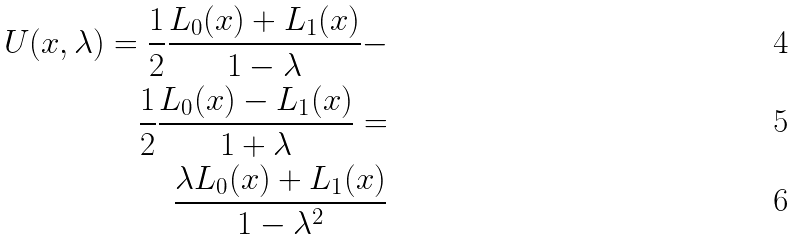<formula> <loc_0><loc_0><loc_500><loc_500>U ( x , \lambda ) = \frac { 1 } { 2 } \frac { L _ { 0 } ( x ) + L _ { 1 } ( x ) } { 1 - \lambda } - \\ \frac { 1 } { 2 } \frac { L _ { 0 } ( x ) - L _ { 1 } ( x ) } { 1 + \lambda } = \\ \frac { \lambda L _ { 0 } ( x ) + L _ { 1 } ( x ) } { 1 - { \lambda } ^ { 2 } }</formula> 